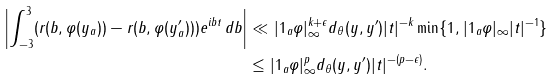<formula> <loc_0><loc_0><loc_500><loc_500>\left | \int _ { - 3 } ^ { 3 } ( r ( b , \varphi ( y _ { a } ) ) - r ( b , \varphi ( y ^ { \prime } _ { a } ) ) ) e ^ { i b t } \, d b \right | & \ll | 1 _ { a } \varphi | _ { \infty } ^ { k + \epsilon } d _ { \theta } ( y , y ^ { \prime } ) | t | ^ { - k } \min \{ 1 , | 1 _ { a } \varphi | _ { \infty } | t | ^ { - 1 } \} \\ & \leq | 1 _ { a } \varphi | _ { \infty } ^ { p } d _ { \theta } ( y , y ^ { \prime } ) | t | ^ { - ( p - \epsilon ) } .</formula> 